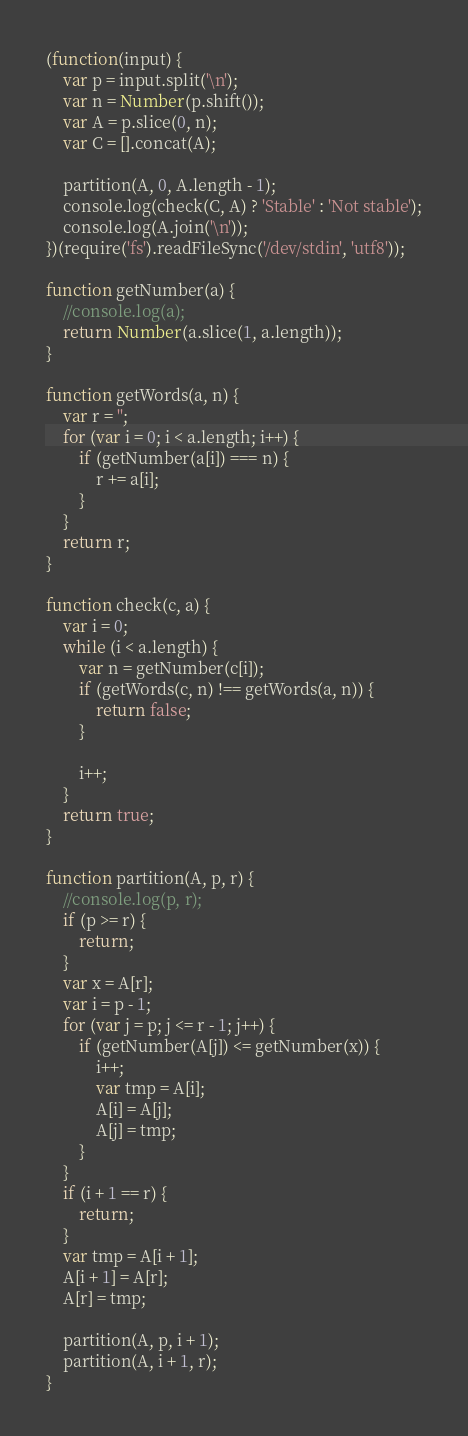Convert code to text. <code><loc_0><loc_0><loc_500><loc_500><_JavaScript_>(function(input) {
    var p = input.split('\n');
    var n = Number(p.shift());
    var A = p.slice(0, n);
    var C = [].concat(A);

    partition(A, 0, A.length - 1);
    console.log(check(C, A) ? 'Stable' : 'Not stable');
    console.log(A.join('\n'));
})(require('fs').readFileSync('/dev/stdin', 'utf8'));

function getNumber(a) {
    //console.log(a);
    return Number(a.slice(1, a.length));
}

function getWords(a, n) {
    var r = '';
    for (var i = 0; i < a.length; i++) {
        if (getNumber(a[i]) === n) {
            r += a[i];
        }
    }
    return r;
}

function check(c, a) {
    var i = 0;
    while (i < a.length) {
        var n = getNumber(c[i]);
        if (getWords(c, n) !== getWords(a, n)) {
            return false;
        }

        i++;
    }
    return true;
}

function partition(A, p, r) {
    //console.log(p, r);
    if (p >= r) {
        return;
    }
    var x = A[r];
    var i = p - 1;
    for (var j = p; j <= r - 1; j++) {
        if (getNumber(A[j]) <= getNumber(x)) {
            i++;
            var tmp = A[i];
            A[i] = A[j];
            A[j] = tmp;
        }
    }
    if (i + 1 == r) {
        return;
    }
    var tmp = A[i + 1];
    A[i + 1] = A[r];
    A[r] = tmp;

    partition(A, p, i + 1);
    partition(A, i + 1, r);
}</code> 